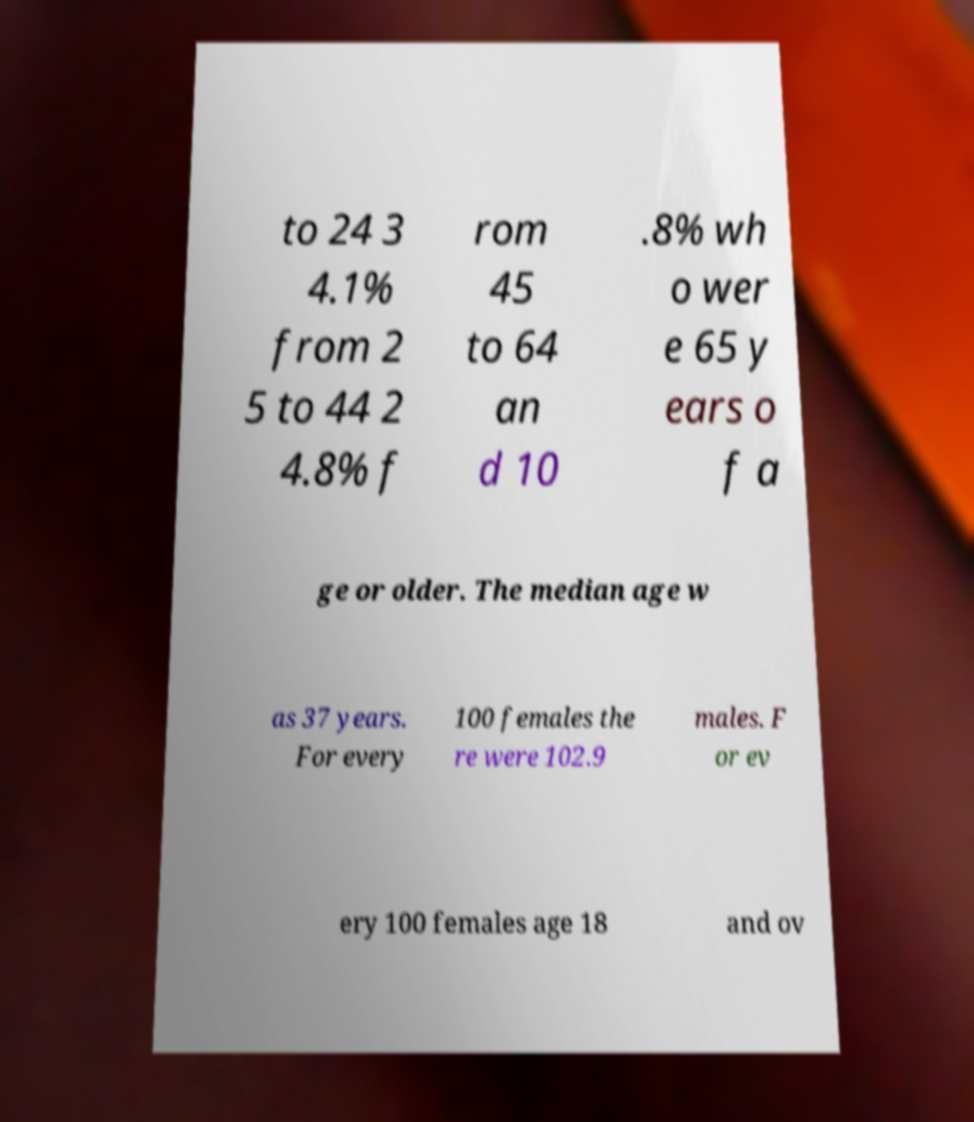Could you assist in decoding the text presented in this image and type it out clearly? to 24 3 4.1% from 2 5 to 44 2 4.8% f rom 45 to 64 an d 10 .8% wh o wer e 65 y ears o f a ge or older. The median age w as 37 years. For every 100 females the re were 102.9 males. F or ev ery 100 females age 18 and ov 